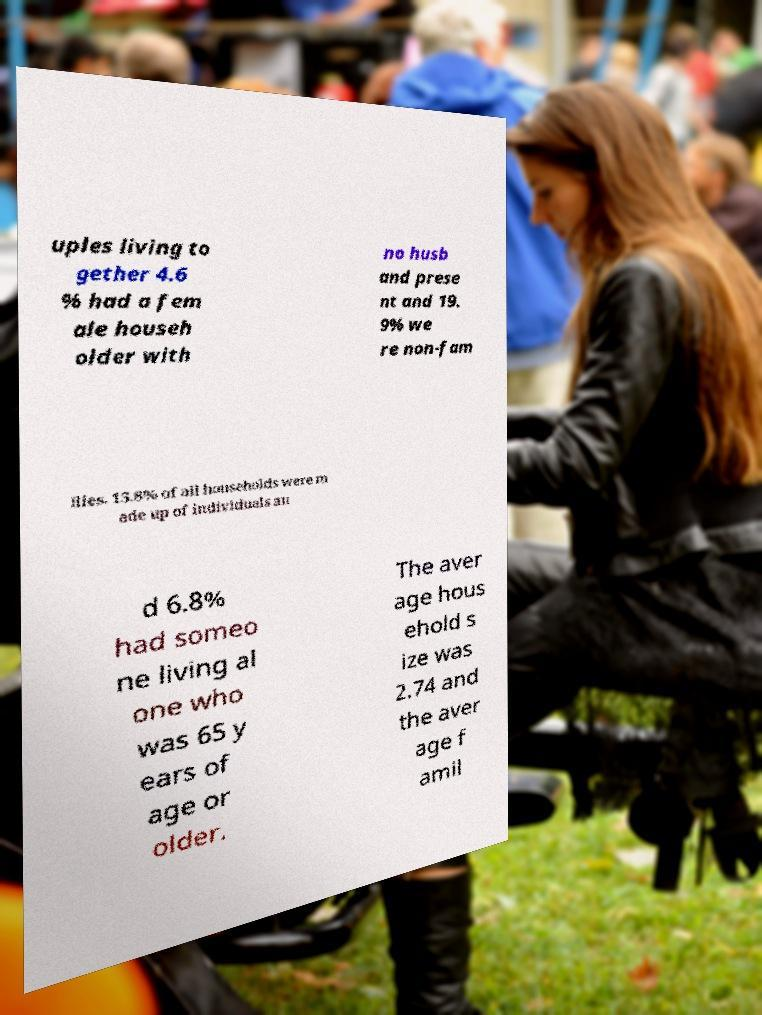Can you accurately transcribe the text from the provided image for me? uples living to gether 4.6 % had a fem ale househ older with no husb and prese nt and 19. 9% we re non-fam ilies. 15.8% of all households were m ade up of individuals an d 6.8% had someo ne living al one who was 65 y ears of age or older. The aver age hous ehold s ize was 2.74 and the aver age f amil 